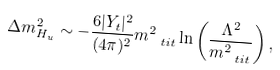<formula> <loc_0><loc_0><loc_500><loc_500>\Delta m ^ { 2 } _ { H _ { u } } \sim - \frac { 6 | Y _ { t } | ^ { 2 } } { ( 4 \pi ) ^ { 2 } } m ^ { 2 } _ { \ t i t } \ln \left ( \frac { \Lambda ^ { 2 } } { m _ { \ t i t } ^ { 2 } } \right ) ,</formula> 